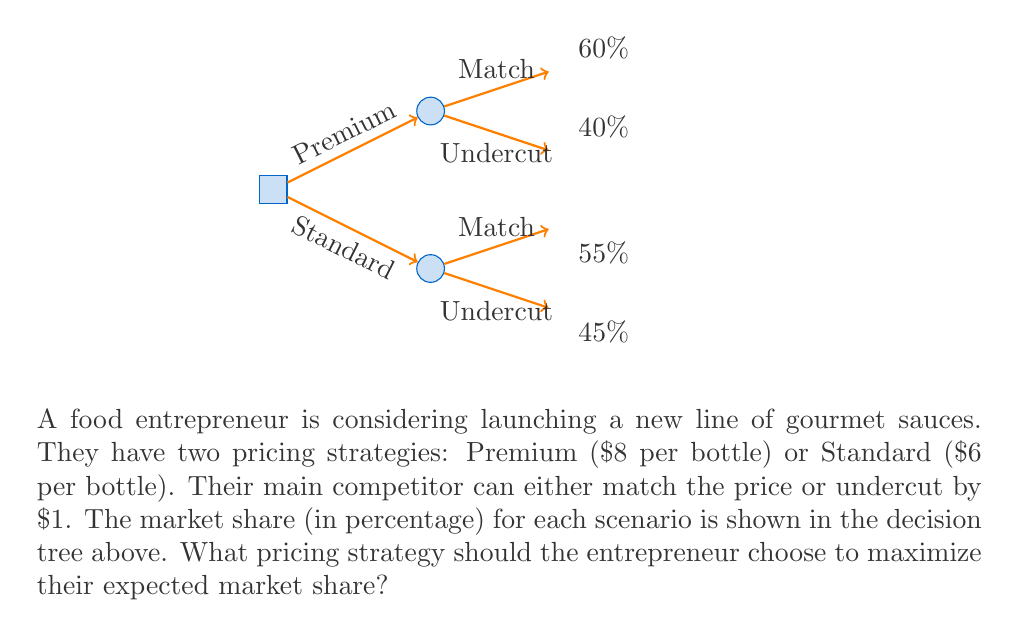What is the answer to this math problem? To solve this problem, we'll use the concept of expected value in decision trees. We'll calculate the expected market share for each pricing strategy and choose the one with the higher value.

1. Premium Strategy ($8 per bottle):
   - If competitor matches: 60% market share
   - If competitor undercuts: 40% market share
   
   Expected market share = $0.5 \times 60\% + 0.5 \times 40\% = 30\% + 20\% = 50\%$

   We assume equal probability (0.5) for each competitor action.

2. Standard Strategy ($6 per bottle):
   - If competitor matches: 55% market share
   - If competitor undercuts: 45% market share
   
   Expected market share = $0.5 \times 55\% + 0.5 \times 45\% = 27.5\% + 22.5\% = 50\%$

   Again, we assume equal probability (0.5) for each competitor action.

3. Comparison:
   Both strategies yield the same expected market share of 50%.

4. Decision:
   Since both strategies have the same expected market share, the entrepreneur should consider other factors:
   - Premium strategy offers higher profit margins per unit sold.
   - Standard strategy may appeal to a broader customer base.
   - The entrepreneur's brand positioning and long-term strategy should be considered.

In this case, given the entrepreneur's experience in the food industry and focus on marketing, the Premium strategy might be more aligned with a gourmet sauce line, allowing for better profit margins and a more upscale brand image.
Answer: Both strategies yield 50% expected market share; choose Premium for higher margins and upscale positioning. 